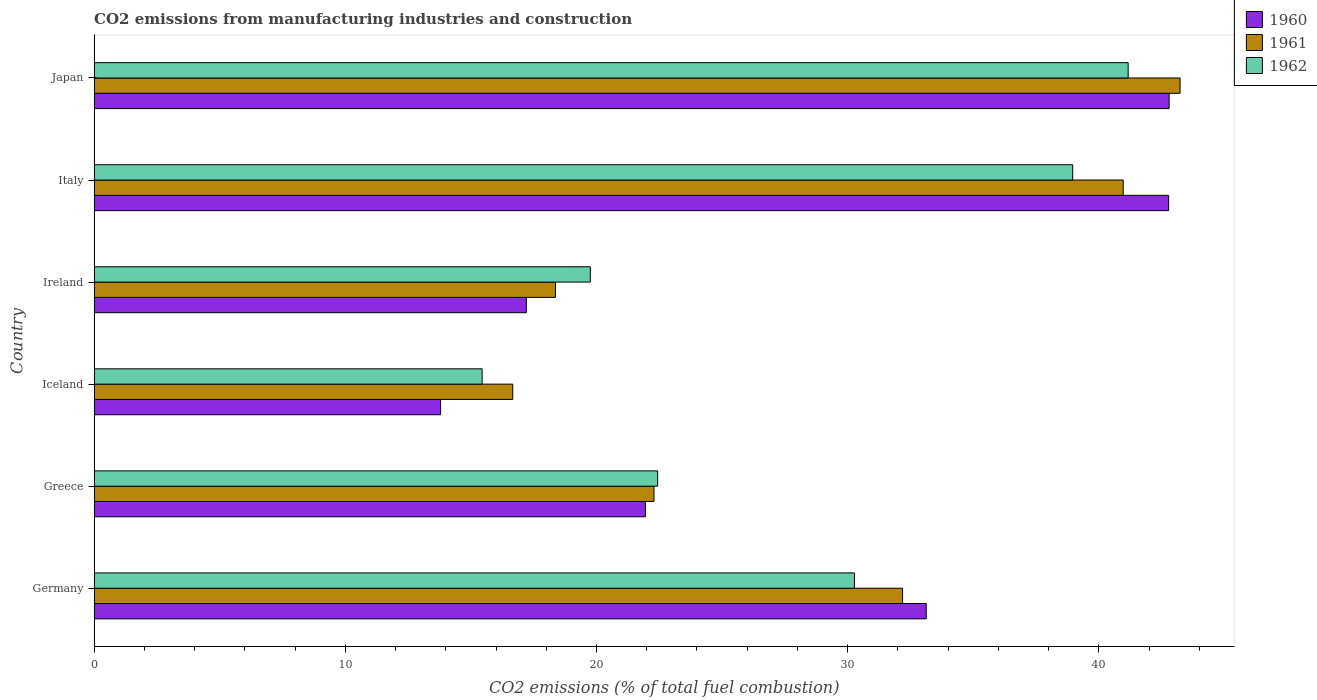Are the number of bars per tick equal to the number of legend labels?
Offer a terse response. Yes. How many bars are there on the 6th tick from the top?
Provide a succinct answer. 3. What is the amount of CO2 emitted in 1962 in Ireland?
Your response must be concise. 19.75. Across all countries, what is the maximum amount of CO2 emitted in 1960?
Give a very brief answer. 42.8. Across all countries, what is the minimum amount of CO2 emitted in 1962?
Your response must be concise. 15.45. In which country was the amount of CO2 emitted in 1961 minimum?
Your response must be concise. Iceland. What is the total amount of CO2 emitted in 1961 in the graph?
Offer a terse response. 173.72. What is the difference between the amount of CO2 emitted in 1960 in Greece and that in Iceland?
Your answer should be very brief. 8.15. What is the difference between the amount of CO2 emitted in 1961 in Germany and the amount of CO2 emitted in 1962 in Iceland?
Provide a succinct answer. 16.74. What is the average amount of CO2 emitted in 1962 per country?
Your answer should be very brief. 28.01. What is the difference between the amount of CO2 emitted in 1961 and amount of CO2 emitted in 1960 in Germany?
Make the answer very short. -0.94. In how many countries, is the amount of CO2 emitted in 1960 greater than 4 %?
Keep it short and to the point. 6. What is the ratio of the amount of CO2 emitted in 1960 in Ireland to that in Japan?
Provide a short and direct response. 0.4. What is the difference between the highest and the second highest amount of CO2 emitted in 1962?
Make the answer very short. 2.21. What is the difference between the highest and the lowest amount of CO2 emitted in 1962?
Your response must be concise. 25.72. In how many countries, is the amount of CO2 emitted in 1960 greater than the average amount of CO2 emitted in 1960 taken over all countries?
Your answer should be very brief. 3. Is the sum of the amount of CO2 emitted in 1961 in Ireland and Japan greater than the maximum amount of CO2 emitted in 1962 across all countries?
Offer a very short reply. Yes. What does the 1st bar from the bottom in Ireland represents?
Your answer should be compact. 1960. How many bars are there?
Provide a short and direct response. 18. Are all the bars in the graph horizontal?
Offer a very short reply. Yes. How many countries are there in the graph?
Your answer should be compact. 6. What is the difference between two consecutive major ticks on the X-axis?
Offer a terse response. 10. Are the values on the major ticks of X-axis written in scientific E-notation?
Keep it short and to the point. No. Does the graph contain grids?
Provide a short and direct response. No. How many legend labels are there?
Offer a very short reply. 3. What is the title of the graph?
Offer a very short reply. CO2 emissions from manufacturing industries and construction. Does "1968" appear as one of the legend labels in the graph?
Make the answer very short. No. What is the label or title of the X-axis?
Your answer should be compact. CO2 emissions (% of total fuel combustion). What is the label or title of the Y-axis?
Your response must be concise. Country. What is the CO2 emissions (% of total fuel combustion) of 1960 in Germany?
Ensure brevity in your answer.  33.13. What is the CO2 emissions (% of total fuel combustion) in 1961 in Germany?
Keep it short and to the point. 32.19. What is the CO2 emissions (% of total fuel combustion) in 1962 in Germany?
Make the answer very short. 30.27. What is the CO2 emissions (% of total fuel combustion) in 1960 in Greece?
Your answer should be compact. 21.95. What is the CO2 emissions (% of total fuel combustion) of 1961 in Greece?
Give a very brief answer. 22.29. What is the CO2 emissions (% of total fuel combustion) in 1962 in Greece?
Provide a succinct answer. 22.44. What is the CO2 emissions (% of total fuel combustion) in 1960 in Iceland?
Make the answer very short. 13.79. What is the CO2 emissions (% of total fuel combustion) in 1961 in Iceland?
Provide a succinct answer. 16.67. What is the CO2 emissions (% of total fuel combustion) in 1962 in Iceland?
Ensure brevity in your answer.  15.45. What is the CO2 emissions (% of total fuel combustion) of 1960 in Ireland?
Offer a terse response. 17.21. What is the CO2 emissions (% of total fuel combustion) of 1961 in Ireland?
Ensure brevity in your answer.  18.37. What is the CO2 emissions (% of total fuel combustion) of 1962 in Ireland?
Your response must be concise. 19.75. What is the CO2 emissions (% of total fuel combustion) of 1960 in Italy?
Your answer should be very brief. 42.78. What is the CO2 emissions (% of total fuel combustion) in 1961 in Italy?
Give a very brief answer. 40.97. What is the CO2 emissions (% of total fuel combustion) in 1962 in Italy?
Keep it short and to the point. 38.96. What is the CO2 emissions (% of total fuel combustion) of 1960 in Japan?
Keep it short and to the point. 42.8. What is the CO2 emissions (% of total fuel combustion) of 1961 in Japan?
Provide a succinct answer. 43.24. What is the CO2 emissions (% of total fuel combustion) in 1962 in Japan?
Offer a terse response. 41.17. Across all countries, what is the maximum CO2 emissions (% of total fuel combustion) in 1960?
Ensure brevity in your answer.  42.8. Across all countries, what is the maximum CO2 emissions (% of total fuel combustion) of 1961?
Ensure brevity in your answer.  43.24. Across all countries, what is the maximum CO2 emissions (% of total fuel combustion) in 1962?
Offer a very short reply. 41.17. Across all countries, what is the minimum CO2 emissions (% of total fuel combustion) of 1960?
Your answer should be compact. 13.79. Across all countries, what is the minimum CO2 emissions (% of total fuel combustion) of 1961?
Give a very brief answer. 16.67. Across all countries, what is the minimum CO2 emissions (% of total fuel combustion) of 1962?
Keep it short and to the point. 15.45. What is the total CO2 emissions (% of total fuel combustion) of 1960 in the graph?
Your answer should be very brief. 171.66. What is the total CO2 emissions (% of total fuel combustion) in 1961 in the graph?
Offer a very short reply. 173.72. What is the total CO2 emissions (% of total fuel combustion) in 1962 in the graph?
Provide a short and direct response. 168.04. What is the difference between the CO2 emissions (% of total fuel combustion) in 1960 in Germany and that in Greece?
Your answer should be compact. 11.18. What is the difference between the CO2 emissions (% of total fuel combustion) in 1961 in Germany and that in Greece?
Make the answer very short. 9.9. What is the difference between the CO2 emissions (% of total fuel combustion) of 1962 in Germany and that in Greece?
Provide a succinct answer. 7.84. What is the difference between the CO2 emissions (% of total fuel combustion) of 1960 in Germany and that in Iceland?
Offer a very short reply. 19.34. What is the difference between the CO2 emissions (% of total fuel combustion) of 1961 in Germany and that in Iceland?
Offer a terse response. 15.52. What is the difference between the CO2 emissions (% of total fuel combustion) of 1962 in Germany and that in Iceland?
Your response must be concise. 14.82. What is the difference between the CO2 emissions (% of total fuel combustion) of 1960 in Germany and that in Ireland?
Offer a terse response. 15.92. What is the difference between the CO2 emissions (% of total fuel combustion) of 1961 in Germany and that in Ireland?
Your response must be concise. 13.82. What is the difference between the CO2 emissions (% of total fuel combustion) of 1962 in Germany and that in Ireland?
Keep it short and to the point. 10.52. What is the difference between the CO2 emissions (% of total fuel combustion) in 1960 in Germany and that in Italy?
Ensure brevity in your answer.  -9.65. What is the difference between the CO2 emissions (% of total fuel combustion) in 1961 in Germany and that in Italy?
Make the answer very short. -8.79. What is the difference between the CO2 emissions (% of total fuel combustion) in 1962 in Germany and that in Italy?
Provide a succinct answer. -8.69. What is the difference between the CO2 emissions (% of total fuel combustion) of 1960 in Germany and that in Japan?
Your response must be concise. -9.67. What is the difference between the CO2 emissions (% of total fuel combustion) in 1961 in Germany and that in Japan?
Offer a terse response. -11.05. What is the difference between the CO2 emissions (% of total fuel combustion) in 1962 in Germany and that in Japan?
Your answer should be very brief. -10.9. What is the difference between the CO2 emissions (% of total fuel combustion) of 1960 in Greece and that in Iceland?
Your answer should be compact. 8.15. What is the difference between the CO2 emissions (% of total fuel combustion) of 1961 in Greece and that in Iceland?
Give a very brief answer. 5.62. What is the difference between the CO2 emissions (% of total fuel combustion) in 1962 in Greece and that in Iceland?
Provide a succinct answer. 6.99. What is the difference between the CO2 emissions (% of total fuel combustion) of 1960 in Greece and that in Ireland?
Provide a succinct answer. 4.74. What is the difference between the CO2 emissions (% of total fuel combustion) of 1961 in Greece and that in Ireland?
Make the answer very short. 3.92. What is the difference between the CO2 emissions (% of total fuel combustion) of 1962 in Greece and that in Ireland?
Keep it short and to the point. 2.68. What is the difference between the CO2 emissions (% of total fuel combustion) in 1960 in Greece and that in Italy?
Provide a short and direct response. -20.83. What is the difference between the CO2 emissions (% of total fuel combustion) in 1961 in Greece and that in Italy?
Provide a short and direct response. -18.68. What is the difference between the CO2 emissions (% of total fuel combustion) in 1962 in Greece and that in Italy?
Keep it short and to the point. -16.53. What is the difference between the CO2 emissions (% of total fuel combustion) in 1960 in Greece and that in Japan?
Provide a succinct answer. -20.85. What is the difference between the CO2 emissions (% of total fuel combustion) of 1961 in Greece and that in Japan?
Make the answer very short. -20.95. What is the difference between the CO2 emissions (% of total fuel combustion) of 1962 in Greece and that in Japan?
Offer a very short reply. -18.73. What is the difference between the CO2 emissions (% of total fuel combustion) of 1960 in Iceland and that in Ireland?
Offer a terse response. -3.41. What is the difference between the CO2 emissions (% of total fuel combustion) in 1961 in Iceland and that in Ireland?
Offer a terse response. -1.7. What is the difference between the CO2 emissions (% of total fuel combustion) of 1962 in Iceland and that in Ireland?
Your answer should be very brief. -4.31. What is the difference between the CO2 emissions (% of total fuel combustion) in 1960 in Iceland and that in Italy?
Your answer should be very brief. -28.99. What is the difference between the CO2 emissions (% of total fuel combustion) in 1961 in Iceland and that in Italy?
Give a very brief answer. -24.31. What is the difference between the CO2 emissions (% of total fuel combustion) in 1962 in Iceland and that in Italy?
Provide a succinct answer. -23.51. What is the difference between the CO2 emissions (% of total fuel combustion) of 1960 in Iceland and that in Japan?
Your answer should be compact. -29.01. What is the difference between the CO2 emissions (% of total fuel combustion) in 1961 in Iceland and that in Japan?
Your answer should be very brief. -26.57. What is the difference between the CO2 emissions (% of total fuel combustion) of 1962 in Iceland and that in Japan?
Provide a succinct answer. -25.72. What is the difference between the CO2 emissions (% of total fuel combustion) of 1960 in Ireland and that in Italy?
Ensure brevity in your answer.  -25.57. What is the difference between the CO2 emissions (% of total fuel combustion) in 1961 in Ireland and that in Italy?
Offer a terse response. -22.61. What is the difference between the CO2 emissions (% of total fuel combustion) of 1962 in Ireland and that in Italy?
Your response must be concise. -19.21. What is the difference between the CO2 emissions (% of total fuel combustion) in 1960 in Ireland and that in Japan?
Provide a succinct answer. -25.6. What is the difference between the CO2 emissions (% of total fuel combustion) in 1961 in Ireland and that in Japan?
Provide a succinct answer. -24.87. What is the difference between the CO2 emissions (% of total fuel combustion) of 1962 in Ireland and that in Japan?
Your answer should be compact. -21.42. What is the difference between the CO2 emissions (% of total fuel combustion) of 1960 in Italy and that in Japan?
Your answer should be compact. -0.02. What is the difference between the CO2 emissions (% of total fuel combustion) of 1961 in Italy and that in Japan?
Offer a very short reply. -2.26. What is the difference between the CO2 emissions (% of total fuel combustion) of 1962 in Italy and that in Japan?
Offer a very short reply. -2.21. What is the difference between the CO2 emissions (% of total fuel combustion) in 1960 in Germany and the CO2 emissions (% of total fuel combustion) in 1961 in Greece?
Provide a short and direct response. 10.84. What is the difference between the CO2 emissions (% of total fuel combustion) in 1960 in Germany and the CO2 emissions (% of total fuel combustion) in 1962 in Greece?
Offer a terse response. 10.69. What is the difference between the CO2 emissions (% of total fuel combustion) in 1961 in Germany and the CO2 emissions (% of total fuel combustion) in 1962 in Greece?
Your response must be concise. 9.75. What is the difference between the CO2 emissions (% of total fuel combustion) of 1960 in Germany and the CO2 emissions (% of total fuel combustion) of 1961 in Iceland?
Provide a succinct answer. 16.46. What is the difference between the CO2 emissions (% of total fuel combustion) of 1960 in Germany and the CO2 emissions (% of total fuel combustion) of 1962 in Iceland?
Provide a succinct answer. 17.68. What is the difference between the CO2 emissions (% of total fuel combustion) of 1961 in Germany and the CO2 emissions (% of total fuel combustion) of 1962 in Iceland?
Your answer should be compact. 16.74. What is the difference between the CO2 emissions (% of total fuel combustion) of 1960 in Germany and the CO2 emissions (% of total fuel combustion) of 1961 in Ireland?
Your answer should be compact. 14.76. What is the difference between the CO2 emissions (% of total fuel combustion) of 1960 in Germany and the CO2 emissions (% of total fuel combustion) of 1962 in Ireland?
Your answer should be compact. 13.38. What is the difference between the CO2 emissions (% of total fuel combustion) in 1961 in Germany and the CO2 emissions (% of total fuel combustion) in 1962 in Ireland?
Ensure brevity in your answer.  12.43. What is the difference between the CO2 emissions (% of total fuel combustion) in 1960 in Germany and the CO2 emissions (% of total fuel combustion) in 1961 in Italy?
Offer a very short reply. -7.84. What is the difference between the CO2 emissions (% of total fuel combustion) in 1960 in Germany and the CO2 emissions (% of total fuel combustion) in 1962 in Italy?
Offer a terse response. -5.83. What is the difference between the CO2 emissions (% of total fuel combustion) of 1961 in Germany and the CO2 emissions (% of total fuel combustion) of 1962 in Italy?
Your response must be concise. -6.77. What is the difference between the CO2 emissions (% of total fuel combustion) of 1960 in Germany and the CO2 emissions (% of total fuel combustion) of 1961 in Japan?
Your response must be concise. -10.11. What is the difference between the CO2 emissions (% of total fuel combustion) in 1960 in Germany and the CO2 emissions (% of total fuel combustion) in 1962 in Japan?
Make the answer very short. -8.04. What is the difference between the CO2 emissions (% of total fuel combustion) of 1961 in Germany and the CO2 emissions (% of total fuel combustion) of 1962 in Japan?
Ensure brevity in your answer.  -8.98. What is the difference between the CO2 emissions (% of total fuel combustion) in 1960 in Greece and the CO2 emissions (% of total fuel combustion) in 1961 in Iceland?
Ensure brevity in your answer.  5.28. What is the difference between the CO2 emissions (% of total fuel combustion) of 1960 in Greece and the CO2 emissions (% of total fuel combustion) of 1962 in Iceland?
Provide a succinct answer. 6.5. What is the difference between the CO2 emissions (% of total fuel combustion) of 1961 in Greece and the CO2 emissions (% of total fuel combustion) of 1962 in Iceland?
Offer a terse response. 6.84. What is the difference between the CO2 emissions (% of total fuel combustion) in 1960 in Greece and the CO2 emissions (% of total fuel combustion) in 1961 in Ireland?
Make the answer very short. 3.58. What is the difference between the CO2 emissions (% of total fuel combustion) in 1960 in Greece and the CO2 emissions (% of total fuel combustion) in 1962 in Ireland?
Provide a short and direct response. 2.19. What is the difference between the CO2 emissions (% of total fuel combustion) of 1961 in Greece and the CO2 emissions (% of total fuel combustion) of 1962 in Ireland?
Your response must be concise. 2.54. What is the difference between the CO2 emissions (% of total fuel combustion) of 1960 in Greece and the CO2 emissions (% of total fuel combustion) of 1961 in Italy?
Your answer should be compact. -19.03. What is the difference between the CO2 emissions (% of total fuel combustion) of 1960 in Greece and the CO2 emissions (% of total fuel combustion) of 1962 in Italy?
Keep it short and to the point. -17.01. What is the difference between the CO2 emissions (% of total fuel combustion) of 1961 in Greece and the CO2 emissions (% of total fuel combustion) of 1962 in Italy?
Your answer should be very brief. -16.67. What is the difference between the CO2 emissions (% of total fuel combustion) in 1960 in Greece and the CO2 emissions (% of total fuel combustion) in 1961 in Japan?
Give a very brief answer. -21.29. What is the difference between the CO2 emissions (% of total fuel combustion) in 1960 in Greece and the CO2 emissions (% of total fuel combustion) in 1962 in Japan?
Make the answer very short. -19.22. What is the difference between the CO2 emissions (% of total fuel combustion) of 1961 in Greece and the CO2 emissions (% of total fuel combustion) of 1962 in Japan?
Ensure brevity in your answer.  -18.88. What is the difference between the CO2 emissions (% of total fuel combustion) in 1960 in Iceland and the CO2 emissions (% of total fuel combustion) in 1961 in Ireland?
Ensure brevity in your answer.  -4.57. What is the difference between the CO2 emissions (% of total fuel combustion) in 1960 in Iceland and the CO2 emissions (% of total fuel combustion) in 1962 in Ireland?
Provide a succinct answer. -5.96. What is the difference between the CO2 emissions (% of total fuel combustion) of 1961 in Iceland and the CO2 emissions (% of total fuel combustion) of 1962 in Ireland?
Your answer should be compact. -3.09. What is the difference between the CO2 emissions (% of total fuel combustion) of 1960 in Iceland and the CO2 emissions (% of total fuel combustion) of 1961 in Italy?
Keep it short and to the point. -27.18. What is the difference between the CO2 emissions (% of total fuel combustion) of 1960 in Iceland and the CO2 emissions (% of total fuel combustion) of 1962 in Italy?
Keep it short and to the point. -25.17. What is the difference between the CO2 emissions (% of total fuel combustion) in 1961 in Iceland and the CO2 emissions (% of total fuel combustion) in 1962 in Italy?
Offer a terse response. -22.29. What is the difference between the CO2 emissions (% of total fuel combustion) in 1960 in Iceland and the CO2 emissions (% of total fuel combustion) in 1961 in Japan?
Your answer should be very brief. -29.44. What is the difference between the CO2 emissions (% of total fuel combustion) of 1960 in Iceland and the CO2 emissions (% of total fuel combustion) of 1962 in Japan?
Keep it short and to the point. -27.38. What is the difference between the CO2 emissions (% of total fuel combustion) of 1961 in Iceland and the CO2 emissions (% of total fuel combustion) of 1962 in Japan?
Provide a short and direct response. -24.5. What is the difference between the CO2 emissions (% of total fuel combustion) in 1960 in Ireland and the CO2 emissions (% of total fuel combustion) in 1961 in Italy?
Keep it short and to the point. -23.77. What is the difference between the CO2 emissions (% of total fuel combustion) in 1960 in Ireland and the CO2 emissions (% of total fuel combustion) in 1962 in Italy?
Your answer should be very brief. -21.75. What is the difference between the CO2 emissions (% of total fuel combustion) in 1961 in Ireland and the CO2 emissions (% of total fuel combustion) in 1962 in Italy?
Offer a very short reply. -20.59. What is the difference between the CO2 emissions (% of total fuel combustion) of 1960 in Ireland and the CO2 emissions (% of total fuel combustion) of 1961 in Japan?
Provide a succinct answer. -26.03. What is the difference between the CO2 emissions (% of total fuel combustion) in 1960 in Ireland and the CO2 emissions (% of total fuel combustion) in 1962 in Japan?
Provide a short and direct response. -23.96. What is the difference between the CO2 emissions (% of total fuel combustion) of 1961 in Ireland and the CO2 emissions (% of total fuel combustion) of 1962 in Japan?
Keep it short and to the point. -22.8. What is the difference between the CO2 emissions (% of total fuel combustion) in 1960 in Italy and the CO2 emissions (% of total fuel combustion) in 1961 in Japan?
Make the answer very short. -0.46. What is the difference between the CO2 emissions (% of total fuel combustion) in 1960 in Italy and the CO2 emissions (% of total fuel combustion) in 1962 in Japan?
Your response must be concise. 1.61. What is the difference between the CO2 emissions (% of total fuel combustion) of 1961 in Italy and the CO2 emissions (% of total fuel combustion) of 1962 in Japan?
Keep it short and to the point. -0.2. What is the average CO2 emissions (% of total fuel combustion) in 1960 per country?
Provide a succinct answer. 28.61. What is the average CO2 emissions (% of total fuel combustion) in 1961 per country?
Keep it short and to the point. 28.95. What is the average CO2 emissions (% of total fuel combustion) of 1962 per country?
Provide a succinct answer. 28.01. What is the difference between the CO2 emissions (% of total fuel combustion) of 1960 and CO2 emissions (% of total fuel combustion) of 1961 in Germany?
Keep it short and to the point. 0.94. What is the difference between the CO2 emissions (% of total fuel combustion) in 1960 and CO2 emissions (% of total fuel combustion) in 1962 in Germany?
Keep it short and to the point. 2.86. What is the difference between the CO2 emissions (% of total fuel combustion) in 1961 and CO2 emissions (% of total fuel combustion) in 1962 in Germany?
Keep it short and to the point. 1.92. What is the difference between the CO2 emissions (% of total fuel combustion) in 1960 and CO2 emissions (% of total fuel combustion) in 1961 in Greece?
Offer a terse response. -0.34. What is the difference between the CO2 emissions (% of total fuel combustion) of 1960 and CO2 emissions (% of total fuel combustion) of 1962 in Greece?
Give a very brief answer. -0.49. What is the difference between the CO2 emissions (% of total fuel combustion) of 1961 and CO2 emissions (% of total fuel combustion) of 1962 in Greece?
Your answer should be very brief. -0.15. What is the difference between the CO2 emissions (% of total fuel combustion) in 1960 and CO2 emissions (% of total fuel combustion) in 1961 in Iceland?
Give a very brief answer. -2.87. What is the difference between the CO2 emissions (% of total fuel combustion) in 1960 and CO2 emissions (% of total fuel combustion) in 1962 in Iceland?
Offer a very short reply. -1.65. What is the difference between the CO2 emissions (% of total fuel combustion) in 1961 and CO2 emissions (% of total fuel combustion) in 1962 in Iceland?
Give a very brief answer. 1.22. What is the difference between the CO2 emissions (% of total fuel combustion) of 1960 and CO2 emissions (% of total fuel combustion) of 1961 in Ireland?
Give a very brief answer. -1.16. What is the difference between the CO2 emissions (% of total fuel combustion) of 1960 and CO2 emissions (% of total fuel combustion) of 1962 in Ireland?
Keep it short and to the point. -2.55. What is the difference between the CO2 emissions (% of total fuel combustion) of 1961 and CO2 emissions (% of total fuel combustion) of 1962 in Ireland?
Give a very brief answer. -1.39. What is the difference between the CO2 emissions (% of total fuel combustion) in 1960 and CO2 emissions (% of total fuel combustion) in 1961 in Italy?
Offer a very short reply. 1.81. What is the difference between the CO2 emissions (% of total fuel combustion) of 1960 and CO2 emissions (% of total fuel combustion) of 1962 in Italy?
Offer a very short reply. 3.82. What is the difference between the CO2 emissions (% of total fuel combustion) of 1961 and CO2 emissions (% of total fuel combustion) of 1962 in Italy?
Keep it short and to the point. 2.01. What is the difference between the CO2 emissions (% of total fuel combustion) in 1960 and CO2 emissions (% of total fuel combustion) in 1961 in Japan?
Offer a terse response. -0.44. What is the difference between the CO2 emissions (% of total fuel combustion) of 1960 and CO2 emissions (% of total fuel combustion) of 1962 in Japan?
Give a very brief answer. 1.63. What is the difference between the CO2 emissions (% of total fuel combustion) in 1961 and CO2 emissions (% of total fuel combustion) in 1962 in Japan?
Your answer should be very brief. 2.07. What is the ratio of the CO2 emissions (% of total fuel combustion) of 1960 in Germany to that in Greece?
Your answer should be compact. 1.51. What is the ratio of the CO2 emissions (% of total fuel combustion) in 1961 in Germany to that in Greece?
Keep it short and to the point. 1.44. What is the ratio of the CO2 emissions (% of total fuel combustion) of 1962 in Germany to that in Greece?
Offer a very short reply. 1.35. What is the ratio of the CO2 emissions (% of total fuel combustion) of 1960 in Germany to that in Iceland?
Ensure brevity in your answer.  2.4. What is the ratio of the CO2 emissions (% of total fuel combustion) of 1961 in Germany to that in Iceland?
Offer a terse response. 1.93. What is the ratio of the CO2 emissions (% of total fuel combustion) in 1962 in Germany to that in Iceland?
Provide a short and direct response. 1.96. What is the ratio of the CO2 emissions (% of total fuel combustion) in 1960 in Germany to that in Ireland?
Your answer should be very brief. 1.93. What is the ratio of the CO2 emissions (% of total fuel combustion) in 1961 in Germany to that in Ireland?
Provide a succinct answer. 1.75. What is the ratio of the CO2 emissions (% of total fuel combustion) of 1962 in Germany to that in Ireland?
Ensure brevity in your answer.  1.53. What is the ratio of the CO2 emissions (% of total fuel combustion) of 1960 in Germany to that in Italy?
Keep it short and to the point. 0.77. What is the ratio of the CO2 emissions (% of total fuel combustion) of 1961 in Germany to that in Italy?
Your answer should be compact. 0.79. What is the ratio of the CO2 emissions (% of total fuel combustion) in 1962 in Germany to that in Italy?
Make the answer very short. 0.78. What is the ratio of the CO2 emissions (% of total fuel combustion) of 1960 in Germany to that in Japan?
Offer a very short reply. 0.77. What is the ratio of the CO2 emissions (% of total fuel combustion) in 1961 in Germany to that in Japan?
Make the answer very short. 0.74. What is the ratio of the CO2 emissions (% of total fuel combustion) of 1962 in Germany to that in Japan?
Ensure brevity in your answer.  0.74. What is the ratio of the CO2 emissions (% of total fuel combustion) in 1960 in Greece to that in Iceland?
Your answer should be compact. 1.59. What is the ratio of the CO2 emissions (% of total fuel combustion) of 1961 in Greece to that in Iceland?
Make the answer very short. 1.34. What is the ratio of the CO2 emissions (% of total fuel combustion) of 1962 in Greece to that in Iceland?
Your answer should be very brief. 1.45. What is the ratio of the CO2 emissions (% of total fuel combustion) in 1960 in Greece to that in Ireland?
Offer a terse response. 1.28. What is the ratio of the CO2 emissions (% of total fuel combustion) of 1961 in Greece to that in Ireland?
Your answer should be compact. 1.21. What is the ratio of the CO2 emissions (% of total fuel combustion) in 1962 in Greece to that in Ireland?
Your response must be concise. 1.14. What is the ratio of the CO2 emissions (% of total fuel combustion) in 1960 in Greece to that in Italy?
Ensure brevity in your answer.  0.51. What is the ratio of the CO2 emissions (% of total fuel combustion) of 1961 in Greece to that in Italy?
Offer a very short reply. 0.54. What is the ratio of the CO2 emissions (% of total fuel combustion) of 1962 in Greece to that in Italy?
Provide a succinct answer. 0.58. What is the ratio of the CO2 emissions (% of total fuel combustion) in 1960 in Greece to that in Japan?
Your answer should be very brief. 0.51. What is the ratio of the CO2 emissions (% of total fuel combustion) in 1961 in Greece to that in Japan?
Keep it short and to the point. 0.52. What is the ratio of the CO2 emissions (% of total fuel combustion) of 1962 in Greece to that in Japan?
Ensure brevity in your answer.  0.54. What is the ratio of the CO2 emissions (% of total fuel combustion) of 1960 in Iceland to that in Ireland?
Your response must be concise. 0.8. What is the ratio of the CO2 emissions (% of total fuel combustion) of 1961 in Iceland to that in Ireland?
Provide a short and direct response. 0.91. What is the ratio of the CO2 emissions (% of total fuel combustion) in 1962 in Iceland to that in Ireland?
Offer a terse response. 0.78. What is the ratio of the CO2 emissions (% of total fuel combustion) of 1960 in Iceland to that in Italy?
Your response must be concise. 0.32. What is the ratio of the CO2 emissions (% of total fuel combustion) of 1961 in Iceland to that in Italy?
Your answer should be compact. 0.41. What is the ratio of the CO2 emissions (% of total fuel combustion) of 1962 in Iceland to that in Italy?
Your response must be concise. 0.4. What is the ratio of the CO2 emissions (% of total fuel combustion) of 1960 in Iceland to that in Japan?
Offer a very short reply. 0.32. What is the ratio of the CO2 emissions (% of total fuel combustion) of 1961 in Iceland to that in Japan?
Make the answer very short. 0.39. What is the ratio of the CO2 emissions (% of total fuel combustion) of 1962 in Iceland to that in Japan?
Ensure brevity in your answer.  0.38. What is the ratio of the CO2 emissions (% of total fuel combustion) of 1960 in Ireland to that in Italy?
Provide a succinct answer. 0.4. What is the ratio of the CO2 emissions (% of total fuel combustion) in 1961 in Ireland to that in Italy?
Offer a terse response. 0.45. What is the ratio of the CO2 emissions (% of total fuel combustion) in 1962 in Ireland to that in Italy?
Keep it short and to the point. 0.51. What is the ratio of the CO2 emissions (% of total fuel combustion) in 1960 in Ireland to that in Japan?
Make the answer very short. 0.4. What is the ratio of the CO2 emissions (% of total fuel combustion) in 1961 in Ireland to that in Japan?
Give a very brief answer. 0.42. What is the ratio of the CO2 emissions (% of total fuel combustion) in 1962 in Ireland to that in Japan?
Offer a very short reply. 0.48. What is the ratio of the CO2 emissions (% of total fuel combustion) of 1961 in Italy to that in Japan?
Offer a very short reply. 0.95. What is the ratio of the CO2 emissions (% of total fuel combustion) of 1962 in Italy to that in Japan?
Offer a terse response. 0.95. What is the difference between the highest and the second highest CO2 emissions (% of total fuel combustion) of 1960?
Your answer should be very brief. 0.02. What is the difference between the highest and the second highest CO2 emissions (% of total fuel combustion) in 1961?
Ensure brevity in your answer.  2.26. What is the difference between the highest and the second highest CO2 emissions (% of total fuel combustion) of 1962?
Your answer should be very brief. 2.21. What is the difference between the highest and the lowest CO2 emissions (% of total fuel combustion) in 1960?
Provide a succinct answer. 29.01. What is the difference between the highest and the lowest CO2 emissions (% of total fuel combustion) in 1961?
Keep it short and to the point. 26.57. What is the difference between the highest and the lowest CO2 emissions (% of total fuel combustion) of 1962?
Offer a terse response. 25.72. 